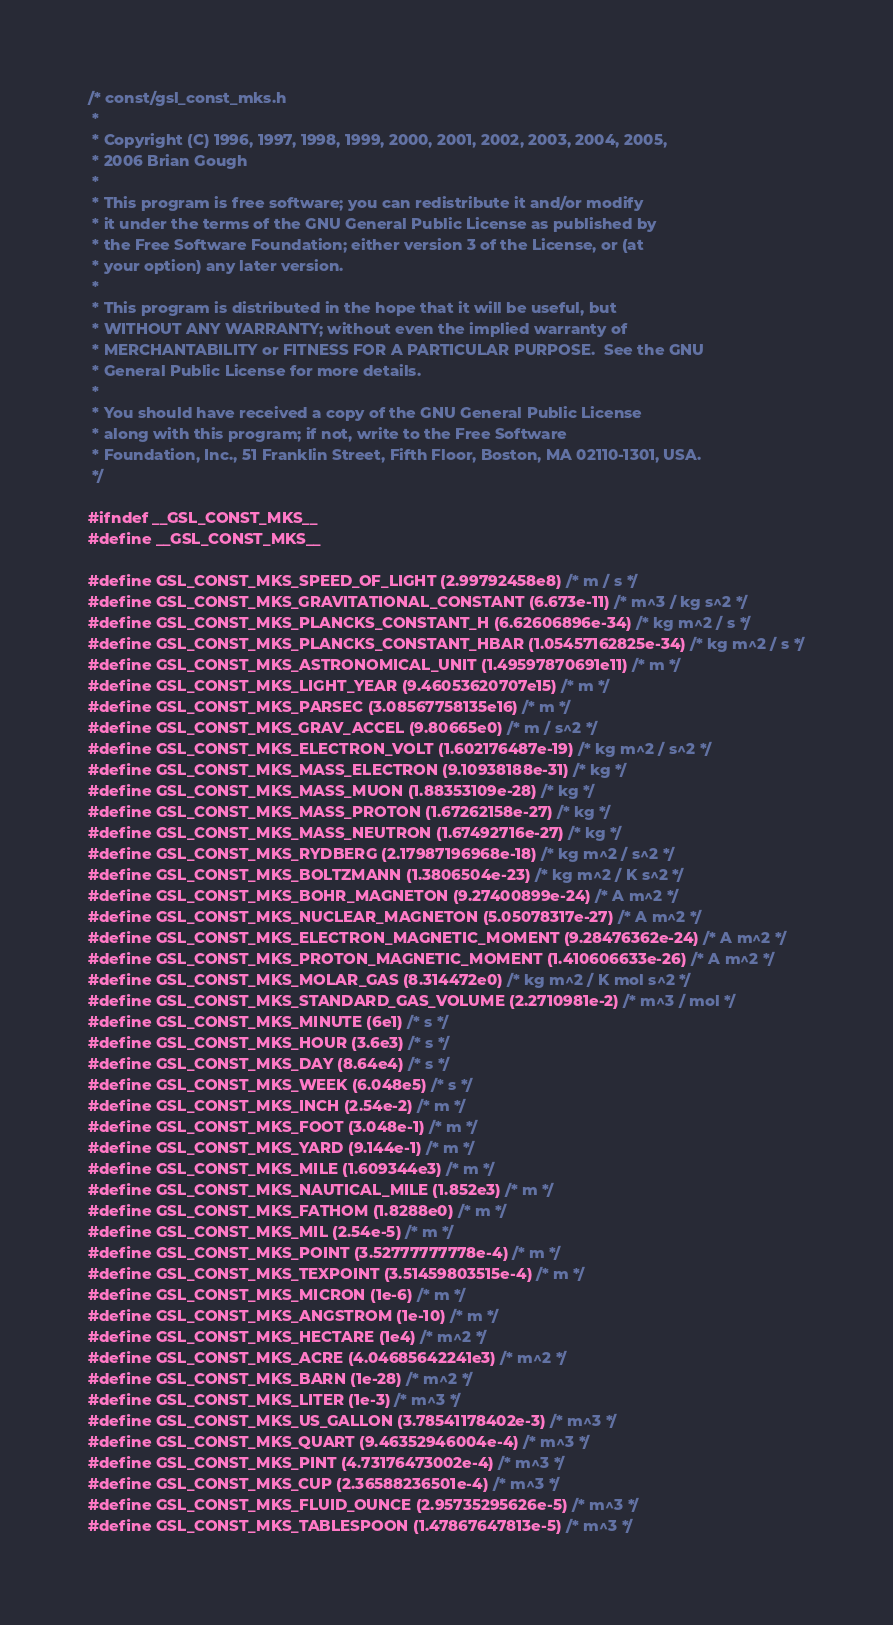<code> <loc_0><loc_0><loc_500><loc_500><_C_>/* const/gsl_const_mks.h
 * 
 * Copyright (C) 1996, 1997, 1998, 1999, 2000, 2001, 2002, 2003, 2004, 2005,
 * 2006 Brian Gough
 * 
 * This program is free software; you can redistribute it and/or modify
 * it under the terms of the GNU General Public License as published by
 * the Free Software Foundation; either version 3 of the License, or (at
 * your option) any later version.
 * 
 * This program is distributed in the hope that it will be useful, but
 * WITHOUT ANY WARRANTY; without even the implied warranty of
 * MERCHANTABILITY or FITNESS FOR A PARTICULAR PURPOSE.  See the GNU
 * General Public License for more details.
 * 
 * You should have received a copy of the GNU General Public License
 * along with this program; if not, write to the Free Software
 * Foundation, Inc., 51 Franklin Street, Fifth Floor, Boston, MA 02110-1301, USA.
 */

#ifndef __GSL_CONST_MKS__
#define __GSL_CONST_MKS__

#define GSL_CONST_MKS_SPEED_OF_LIGHT (2.99792458e8) /* m / s */
#define GSL_CONST_MKS_GRAVITATIONAL_CONSTANT (6.673e-11) /* m^3 / kg s^2 */
#define GSL_CONST_MKS_PLANCKS_CONSTANT_H (6.62606896e-34) /* kg m^2 / s */
#define GSL_CONST_MKS_PLANCKS_CONSTANT_HBAR (1.05457162825e-34) /* kg m^2 / s */
#define GSL_CONST_MKS_ASTRONOMICAL_UNIT (1.49597870691e11) /* m */
#define GSL_CONST_MKS_LIGHT_YEAR (9.46053620707e15) /* m */
#define GSL_CONST_MKS_PARSEC (3.08567758135e16) /* m */
#define GSL_CONST_MKS_GRAV_ACCEL (9.80665e0) /* m / s^2 */
#define GSL_CONST_MKS_ELECTRON_VOLT (1.602176487e-19) /* kg m^2 / s^2 */
#define GSL_CONST_MKS_MASS_ELECTRON (9.10938188e-31) /* kg */
#define GSL_CONST_MKS_MASS_MUON (1.88353109e-28) /* kg */
#define GSL_CONST_MKS_MASS_PROTON (1.67262158e-27) /* kg */
#define GSL_CONST_MKS_MASS_NEUTRON (1.67492716e-27) /* kg */
#define GSL_CONST_MKS_RYDBERG (2.17987196968e-18) /* kg m^2 / s^2 */
#define GSL_CONST_MKS_BOLTZMANN (1.3806504e-23) /* kg m^2 / K s^2 */
#define GSL_CONST_MKS_BOHR_MAGNETON (9.27400899e-24) /* A m^2 */
#define GSL_CONST_MKS_NUCLEAR_MAGNETON (5.05078317e-27) /* A m^2 */
#define GSL_CONST_MKS_ELECTRON_MAGNETIC_MOMENT (9.28476362e-24) /* A m^2 */
#define GSL_CONST_MKS_PROTON_MAGNETIC_MOMENT (1.410606633e-26) /* A m^2 */
#define GSL_CONST_MKS_MOLAR_GAS (8.314472e0) /* kg m^2 / K mol s^2 */
#define GSL_CONST_MKS_STANDARD_GAS_VOLUME (2.2710981e-2) /* m^3 / mol */
#define GSL_CONST_MKS_MINUTE (6e1) /* s */
#define GSL_CONST_MKS_HOUR (3.6e3) /* s */
#define GSL_CONST_MKS_DAY (8.64e4) /* s */
#define GSL_CONST_MKS_WEEK (6.048e5) /* s */
#define GSL_CONST_MKS_INCH (2.54e-2) /* m */
#define GSL_CONST_MKS_FOOT (3.048e-1) /* m */
#define GSL_CONST_MKS_YARD (9.144e-1) /* m */
#define GSL_CONST_MKS_MILE (1.609344e3) /* m */
#define GSL_CONST_MKS_NAUTICAL_MILE (1.852e3) /* m */
#define GSL_CONST_MKS_FATHOM (1.8288e0) /* m */
#define GSL_CONST_MKS_MIL (2.54e-5) /* m */
#define GSL_CONST_MKS_POINT (3.52777777778e-4) /* m */
#define GSL_CONST_MKS_TEXPOINT (3.51459803515e-4) /* m */
#define GSL_CONST_MKS_MICRON (1e-6) /* m */
#define GSL_CONST_MKS_ANGSTROM (1e-10) /* m */
#define GSL_CONST_MKS_HECTARE (1e4) /* m^2 */
#define GSL_CONST_MKS_ACRE (4.04685642241e3) /* m^2 */
#define GSL_CONST_MKS_BARN (1e-28) /* m^2 */
#define GSL_CONST_MKS_LITER (1e-3) /* m^3 */
#define GSL_CONST_MKS_US_GALLON (3.78541178402e-3) /* m^3 */
#define GSL_CONST_MKS_QUART (9.46352946004e-4) /* m^3 */
#define GSL_CONST_MKS_PINT (4.73176473002e-4) /* m^3 */
#define GSL_CONST_MKS_CUP (2.36588236501e-4) /* m^3 */
#define GSL_CONST_MKS_FLUID_OUNCE (2.95735295626e-5) /* m^3 */
#define GSL_CONST_MKS_TABLESPOON (1.47867647813e-5) /* m^3 */</code> 